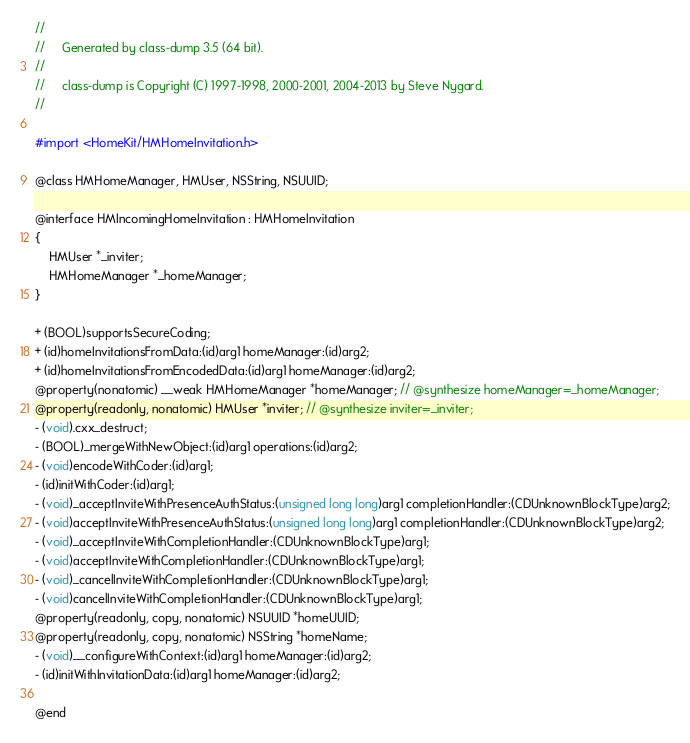<code> <loc_0><loc_0><loc_500><loc_500><_C_>//
//     Generated by class-dump 3.5 (64 bit).
//
//     class-dump is Copyright (C) 1997-1998, 2000-2001, 2004-2013 by Steve Nygard.
//

#import <HomeKit/HMHomeInvitation.h>

@class HMHomeManager, HMUser, NSString, NSUUID;

@interface HMIncomingHomeInvitation : HMHomeInvitation
{
    HMUser *_inviter;
    HMHomeManager *_homeManager;
}

+ (BOOL)supportsSecureCoding;
+ (id)homeInvitationsFromData:(id)arg1 homeManager:(id)arg2;
+ (id)homeInvitationsFromEncodedData:(id)arg1 homeManager:(id)arg2;
@property(nonatomic) __weak HMHomeManager *homeManager; // @synthesize homeManager=_homeManager;
@property(readonly, nonatomic) HMUser *inviter; // @synthesize inviter=_inviter;
- (void).cxx_destruct;
- (BOOL)_mergeWithNewObject:(id)arg1 operations:(id)arg2;
- (void)encodeWithCoder:(id)arg1;
- (id)initWithCoder:(id)arg1;
- (void)_acceptInviteWithPresenceAuthStatus:(unsigned long long)arg1 completionHandler:(CDUnknownBlockType)arg2;
- (void)acceptInviteWithPresenceAuthStatus:(unsigned long long)arg1 completionHandler:(CDUnknownBlockType)arg2;
- (void)_acceptInviteWithCompletionHandler:(CDUnknownBlockType)arg1;
- (void)acceptInviteWithCompletionHandler:(CDUnknownBlockType)arg1;
- (void)_cancelInviteWithCompletionHandler:(CDUnknownBlockType)arg1;
- (void)cancelInviteWithCompletionHandler:(CDUnknownBlockType)arg1;
@property(readonly, copy, nonatomic) NSUUID *homeUUID;
@property(readonly, copy, nonatomic) NSString *homeName;
- (void)__configureWithContext:(id)arg1 homeManager:(id)arg2;
- (id)initWithInvitationData:(id)arg1 homeManager:(id)arg2;

@end

</code> 